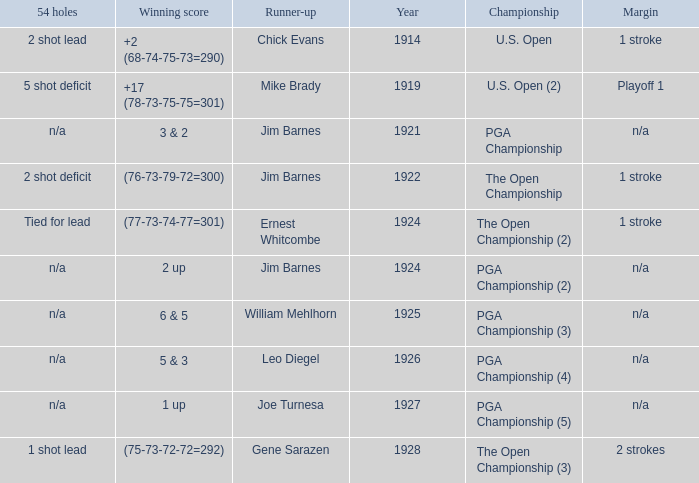WHAT YEAR WAS IT WHEN THE SCORE WAS 3 & 2? 1921.0. 